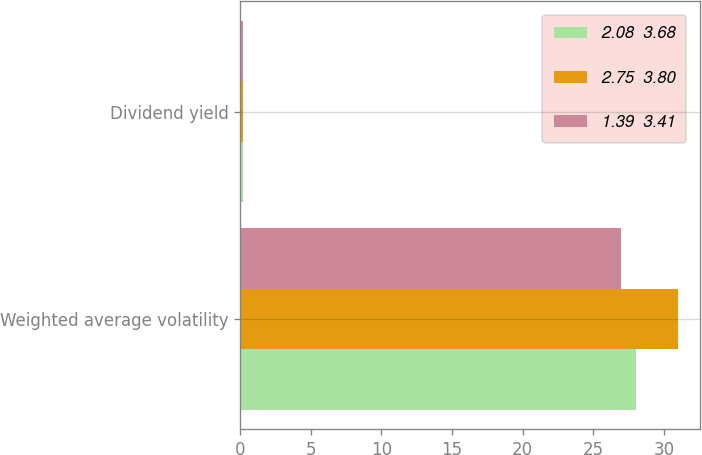Convert chart. <chart><loc_0><loc_0><loc_500><loc_500><stacked_bar_chart><ecel><fcel>Weighted average volatility<fcel>Dividend yield<nl><fcel>2.08  3.68<fcel>28<fcel>0.2<nl><fcel>2.75  3.80<fcel>31<fcel>0.2<nl><fcel>1.39  3.41<fcel>27<fcel>0.2<nl></chart> 